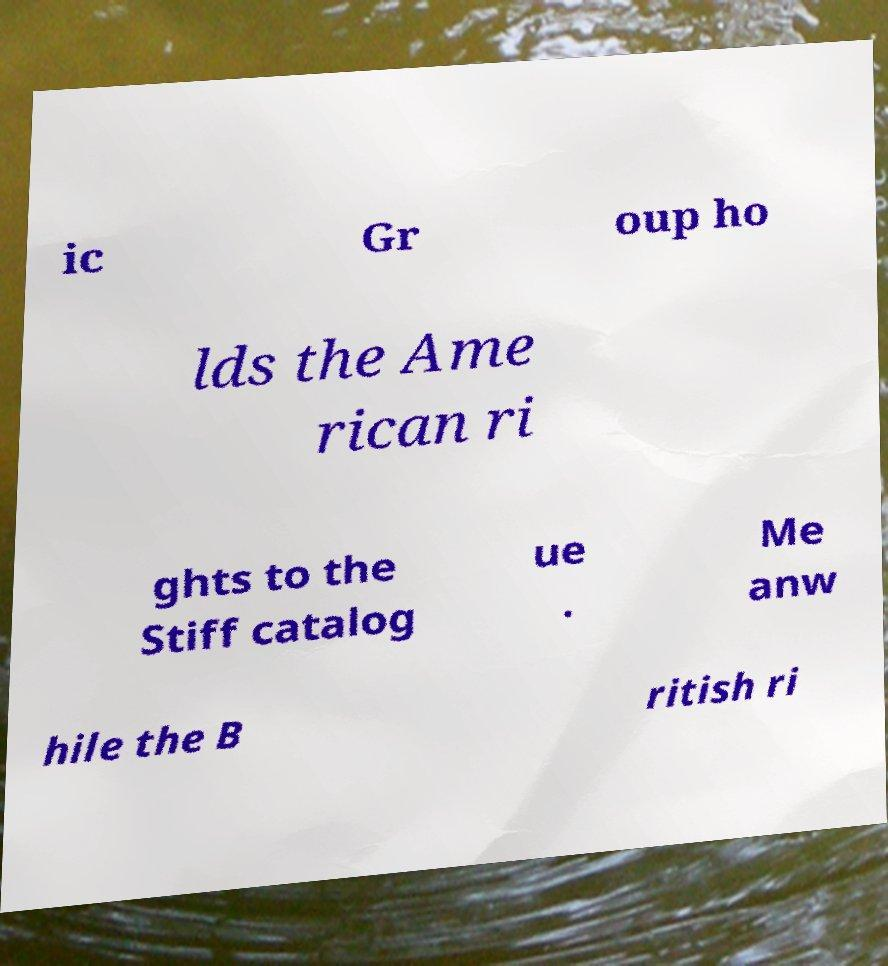Please read and relay the text visible in this image. What does it say? ic Gr oup ho lds the Ame rican ri ghts to the Stiff catalog ue . Me anw hile the B ritish ri 